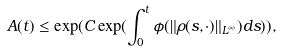<formula> <loc_0><loc_0><loc_500><loc_500>A ( t ) \leq \exp ( C \exp ( \int ^ { t } _ { 0 } \phi ( \| \rho ( s , \cdot ) \| _ { L ^ { \infty } } ) d s ) ) ,</formula> 